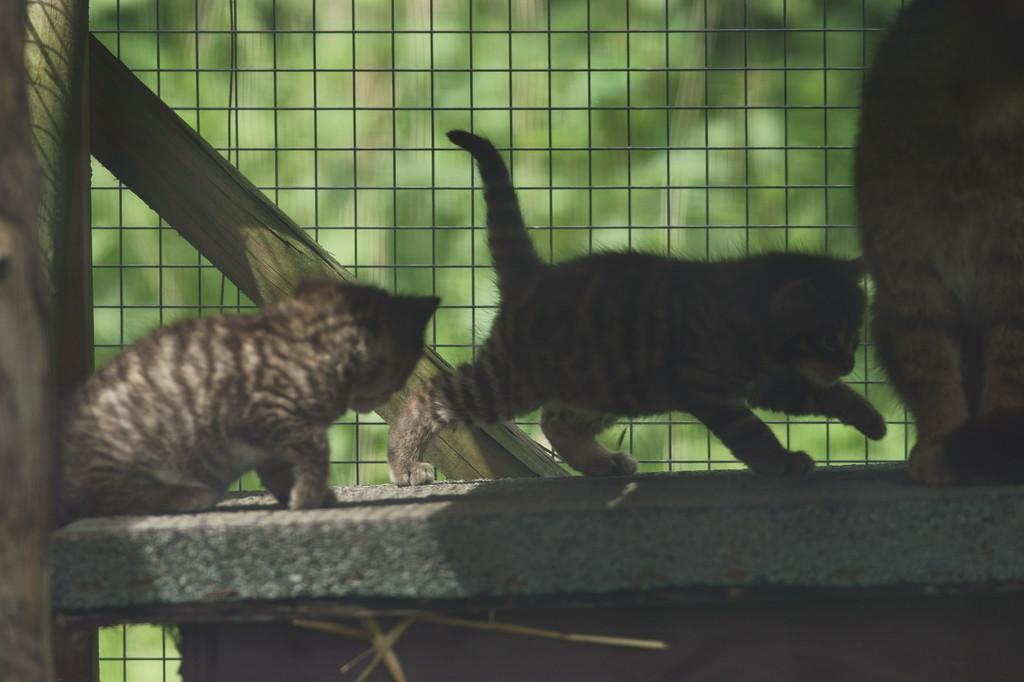Please provide a concise description of this image. In this image in the center there are animals on the floor and behind the animals there is a wooden stand and there is a fence and the background is blurry. 